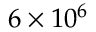<formula> <loc_0><loc_0><loc_500><loc_500>6 \times 1 0 ^ { 6 }</formula> 